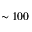Convert formula to latex. <formula><loc_0><loc_0><loc_500><loc_500>\sim 1 0 0</formula> 